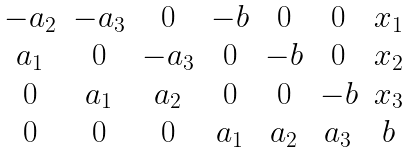<formula> <loc_0><loc_0><loc_500><loc_500>\begin{matrix} - a _ { 2 } & - a _ { 3 } & 0 & - b & 0 & 0 & x _ { 1 } \\ a _ { 1 } & 0 & - a _ { 3 } & 0 & - b & 0 & x _ { 2 } \\ 0 & a _ { 1 } & a _ { 2 } & 0 & 0 & - b & x _ { 3 } \\ 0 & 0 & 0 & a _ { 1 } & a _ { 2 } & a _ { 3 } & b \end{matrix}</formula> 